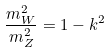Convert formula to latex. <formula><loc_0><loc_0><loc_500><loc_500>\frac { m _ { W } ^ { 2 } } { m _ { Z } ^ { 2 } } = 1 - k ^ { 2 }</formula> 